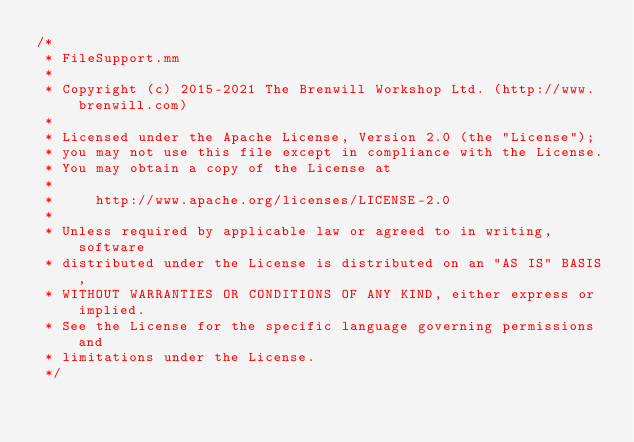<code> <loc_0><loc_0><loc_500><loc_500><_ObjectiveC_>/*
 * FileSupport.mm
 *
 * Copyright (c) 2015-2021 The Brenwill Workshop Ltd. (http://www.brenwill.com)
 *
 * Licensed under the Apache License, Version 2.0 (the "License");
 * you may not use this file except in compliance with the License.
 * You may obtain a copy of the License at
 * 
 *     http://www.apache.org/licenses/LICENSE-2.0
 * 
 * Unless required by applicable law or agreed to in writing, software
 * distributed under the License is distributed on an "AS IS" BASIS,
 * WITHOUT WARRANTIES OR CONDITIONS OF ANY KIND, either express or implied.
 * See the License for the specific language governing permissions and
 * limitations under the License.
 */
</code> 